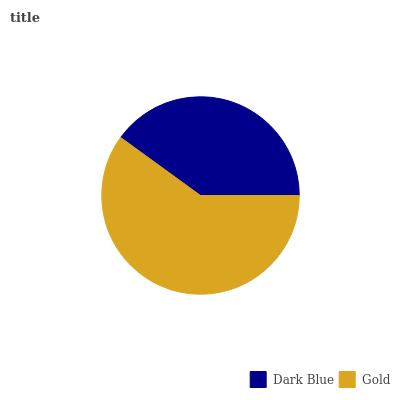Is Dark Blue the minimum?
Answer yes or no. Yes. Is Gold the maximum?
Answer yes or no. Yes. Is Gold the minimum?
Answer yes or no. No. Is Gold greater than Dark Blue?
Answer yes or no. Yes. Is Dark Blue less than Gold?
Answer yes or no. Yes. Is Dark Blue greater than Gold?
Answer yes or no. No. Is Gold less than Dark Blue?
Answer yes or no. No. Is Gold the high median?
Answer yes or no. Yes. Is Dark Blue the low median?
Answer yes or no. Yes. Is Dark Blue the high median?
Answer yes or no. No. Is Gold the low median?
Answer yes or no. No. 